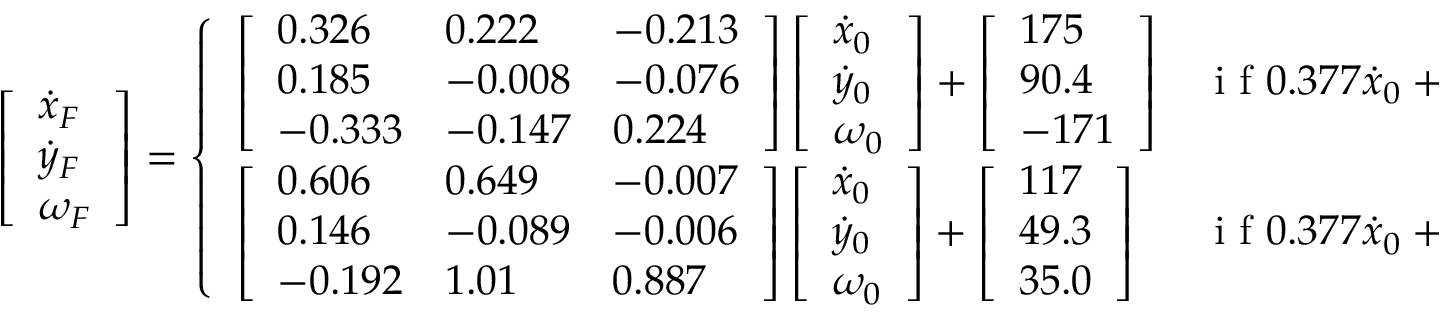<formula> <loc_0><loc_0><loc_500><loc_500>\left [ \begin{array} { l } { \dot { x } _ { F } } \\ { \dot { y } _ { F } } \\ { \omega _ { F } } \end{array} \right ] = \left \{ \begin{array} { l l } { \left [ \begin{array} { l l l } { 0 . 3 2 6 } & { 0 . 2 2 2 } & { - 0 . 2 1 3 } \\ { 0 . 1 8 5 } & { - 0 . 0 0 8 } & { - 0 . 0 7 6 } \\ { - 0 . 3 3 3 } & { - 0 . 1 4 7 } & { 0 . 2 2 4 } \end{array} \right ] \left [ \begin{array} { l } { \dot { x } _ { 0 } } \\ { \dot { y } _ { 0 } } \\ { \omega _ { 0 } } \end{array} \right ] + \left [ \begin{array} { l } { 1 7 5 } \\ { 9 0 . 4 } \\ { - 1 7 1 } \end{array} \right ] } & { i f 0 . 3 7 7 \dot { x } _ { 0 } + 2 . 2 5 \dot { y } _ { 0 } + \omega _ { 0 } < - 4 8 5 } \\ { \left [ \begin{array} { l l l } { 0 . 6 0 6 } & { 0 . 6 4 9 } & { - 0 . 0 0 7 } \\ { 0 . 1 4 6 } & { - 0 . 0 8 9 } & { - 0 . 0 0 6 } \\ { - 0 . 1 9 2 } & { 1 . 0 1 } & { 0 . 8 8 7 } \end{array} \right ] \left [ \begin{array} { l } { \dot { x } _ { 0 } } \\ { \dot { y } _ { 0 } } \\ { \omega _ { 0 } } \end{array} \right ] + \left [ \begin{array} { l } { 1 1 7 } \\ { 4 9 . 3 } \\ { 3 5 . 0 } \end{array} \right ] } & { i f 0 . 3 7 7 \dot { x } _ { 0 } + 2 . 2 5 \dot { y } _ { 0 } + \omega _ { 0 } > - 4 8 5 . } \end{array}</formula> 